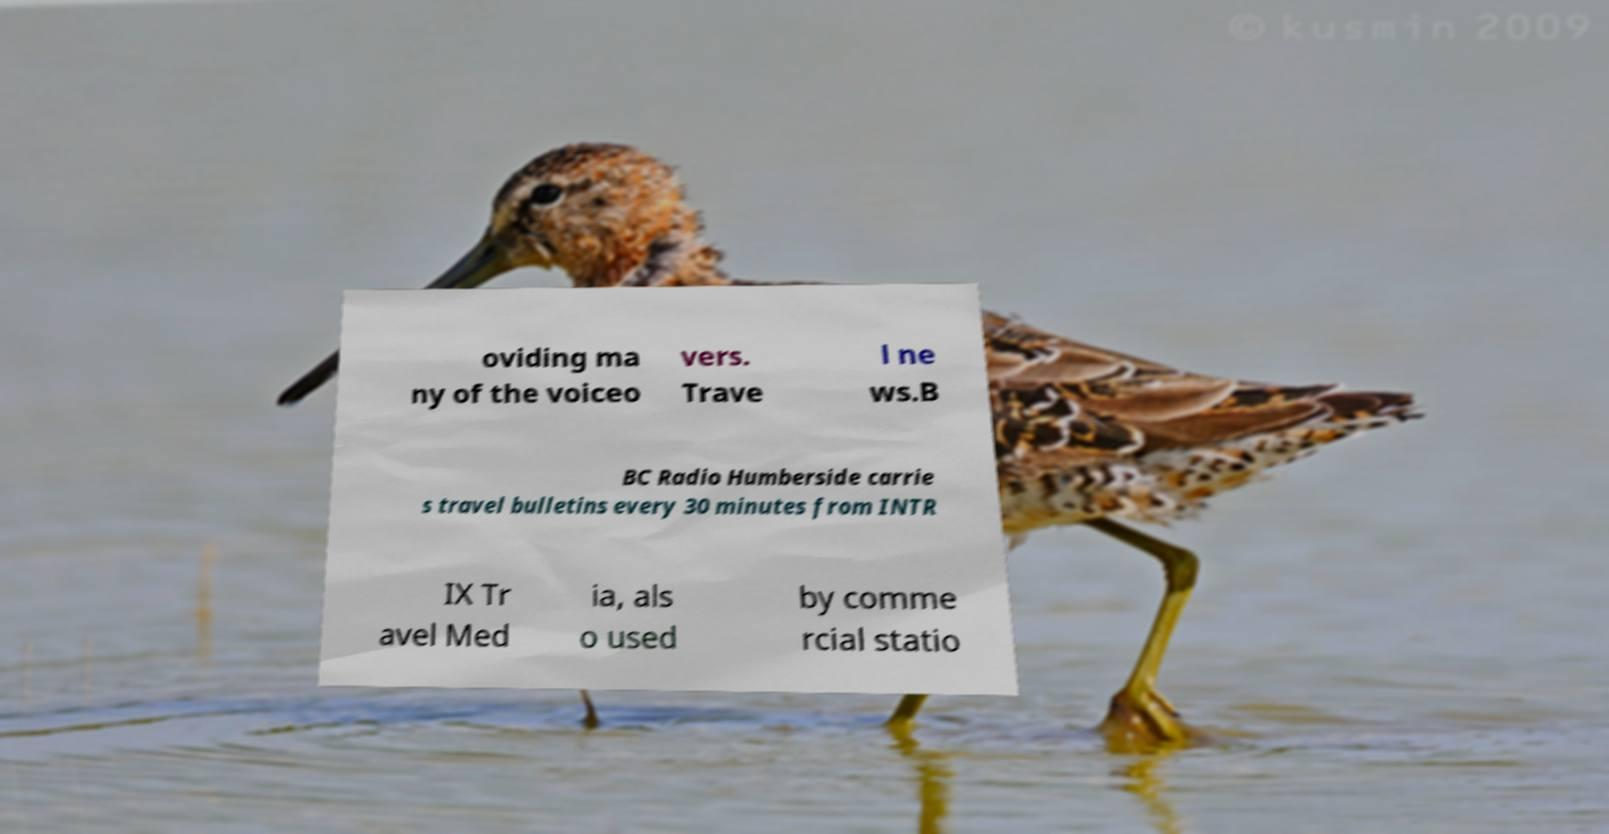I need the written content from this picture converted into text. Can you do that? oviding ma ny of the voiceo vers. Trave l ne ws.B BC Radio Humberside carrie s travel bulletins every 30 minutes from INTR IX Tr avel Med ia, als o used by comme rcial statio 